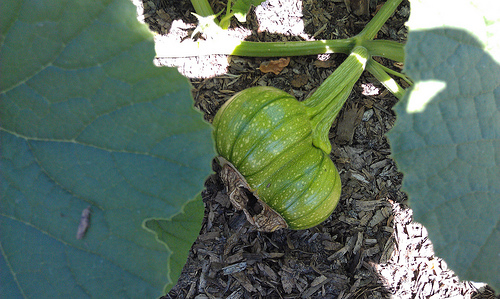<image>
Is the gourd on the leaf? No. The gourd is not positioned on the leaf. They may be near each other, but the gourd is not supported by or resting on top of the leaf. 